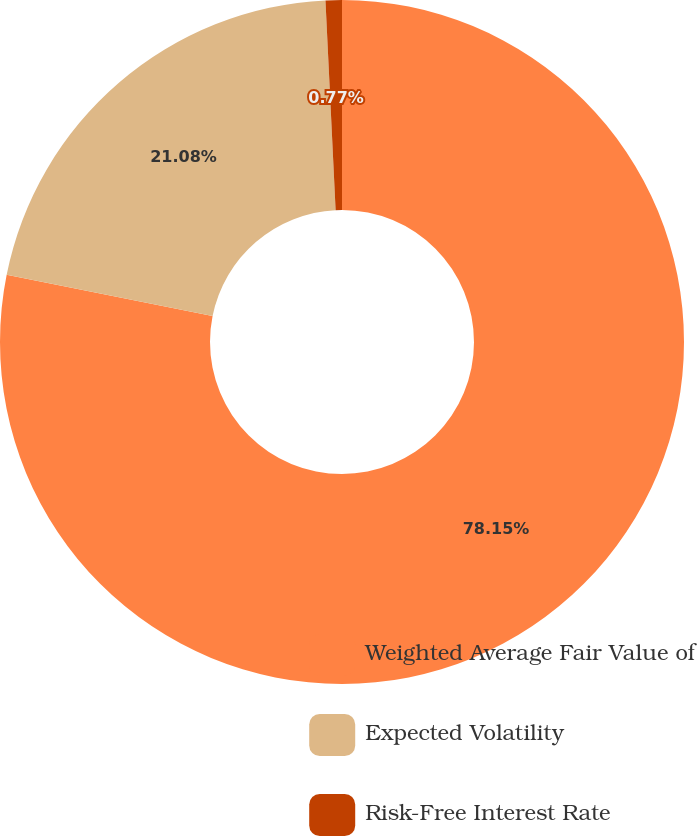<chart> <loc_0><loc_0><loc_500><loc_500><pie_chart><fcel>Weighted Average Fair Value of<fcel>Expected Volatility<fcel>Risk-Free Interest Rate<nl><fcel>78.14%<fcel>21.08%<fcel>0.77%<nl></chart> 